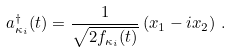Convert formula to latex. <formula><loc_0><loc_0><loc_500><loc_500>a ^ { \dag } _ { \kappa _ { i } } ( t ) = \frac { 1 } { \sqrt { 2 f _ { \kappa _ { i } } ( { t } ) } } \left ( x _ { 1 } - i x _ { 2 } \right ) \, .</formula> 